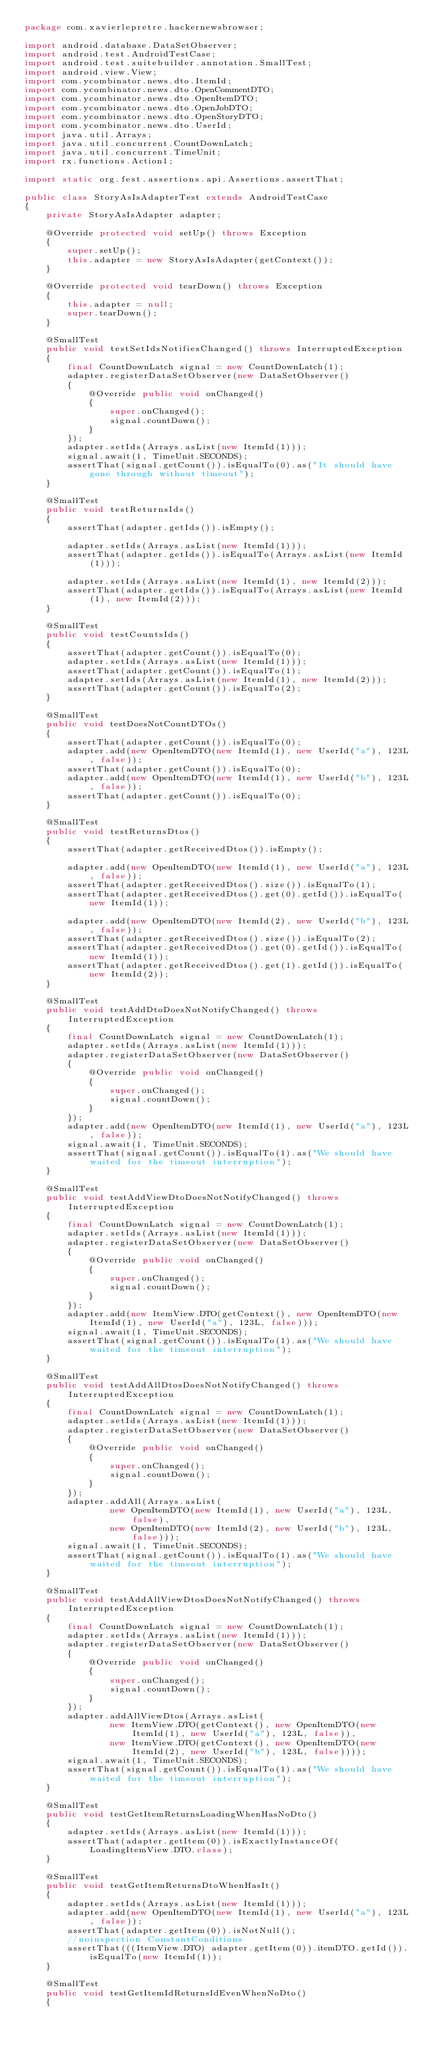<code> <loc_0><loc_0><loc_500><loc_500><_Java_>package com.xavierlepretre.hackernewsbrowser;

import android.database.DataSetObserver;
import android.test.AndroidTestCase;
import android.test.suitebuilder.annotation.SmallTest;
import android.view.View;
import com.ycombinator.news.dto.ItemId;
import com.ycombinator.news.dto.OpenCommentDTO;
import com.ycombinator.news.dto.OpenItemDTO;
import com.ycombinator.news.dto.OpenJobDTO;
import com.ycombinator.news.dto.OpenStoryDTO;
import com.ycombinator.news.dto.UserId;
import java.util.Arrays;
import java.util.concurrent.CountDownLatch;
import java.util.concurrent.TimeUnit;
import rx.functions.Action1;

import static org.fest.assertions.api.Assertions.assertThat;

public class StoryAsIsAdapterTest extends AndroidTestCase
{
    private StoryAsIsAdapter adapter;

    @Override protected void setUp() throws Exception
    {
        super.setUp();
        this.adapter = new StoryAsIsAdapter(getContext());
    }

    @Override protected void tearDown() throws Exception
    {
        this.adapter = null;
        super.tearDown();
    }

    @SmallTest
    public void testSetIdsNotifiesChanged() throws InterruptedException
    {
        final CountDownLatch signal = new CountDownLatch(1);
        adapter.registerDataSetObserver(new DataSetObserver()
        {
            @Override public void onChanged()
            {
                super.onChanged();
                signal.countDown();
            }
        });
        adapter.setIds(Arrays.asList(new ItemId(1)));
        signal.await(1, TimeUnit.SECONDS);
        assertThat(signal.getCount()).isEqualTo(0).as("It should have gone through without timeout");
    }

    @SmallTest
    public void testReturnsIds()
    {
        assertThat(adapter.getIds()).isEmpty();

        adapter.setIds(Arrays.asList(new ItemId(1)));
        assertThat(adapter.getIds()).isEqualTo(Arrays.asList(new ItemId(1)));

        adapter.setIds(Arrays.asList(new ItemId(1), new ItemId(2)));
        assertThat(adapter.getIds()).isEqualTo(Arrays.asList(new ItemId(1), new ItemId(2)));
    }

    @SmallTest
    public void testCountsIds()
    {
        assertThat(adapter.getCount()).isEqualTo(0);
        adapter.setIds(Arrays.asList(new ItemId(1)));
        assertThat(adapter.getCount()).isEqualTo(1);
        adapter.setIds(Arrays.asList(new ItemId(1), new ItemId(2)));
        assertThat(adapter.getCount()).isEqualTo(2);
    }

    @SmallTest
    public void testDoesNotCountDTOs()
    {
        assertThat(adapter.getCount()).isEqualTo(0);
        adapter.add(new OpenItemDTO(new ItemId(1), new UserId("a"), 123L, false));
        assertThat(adapter.getCount()).isEqualTo(0);
        adapter.add(new OpenItemDTO(new ItemId(1), new UserId("b"), 123L, false));
        assertThat(adapter.getCount()).isEqualTo(0);
    }

    @SmallTest
    public void testReturnsDtos()
    {
        assertThat(adapter.getReceivedDtos()).isEmpty();

        adapter.add(new OpenItemDTO(new ItemId(1), new UserId("a"), 123L, false));
        assertThat(adapter.getReceivedDtos().size()).isEqualTo(1);
        assertThat(adapter.getReceivedDtos().get(0).getId()).isEqualTo(new ItemId(1));

        adapter.add(new OpenItemDTO(new ItemId(2), new UserId("b"), 123L, false));
        assertThat(adapter.getReceivedDtos().size()).isEqualTo(2);
        assertThat(adapter.getReceivedDtos().get(0).getId()).isEqualTo(new ItemId(1));
        assertThat(adapter.getReceivedDtos().get(1).getId()).isEqualTo(new ItemId(2));
    }

    @SmallTest
    public void testAddDtoDoesNotNotifyChanged() throws InterruptedException
    {
        final CountDownLatch signal = new CountDownLatch(1);
        adapter.setIds(Arrays.asList(new ItemId(1)));
        adapter.registerDataSetObserver(new DataSetObserver()
        {
            @Override public void onChanged()
            {
                super.onChanged();
                signal.countDown();
            }
        });
        adapter.add(new OpenItemDTO(new ItemId(1), new UserId("a"), 123L, false));
        signal.await(1, TimeUnit.SECONDS);
        assertThat(signal.getCount()).isEqualTo(1).as("We should have waited for the timeout interruption");
    }

    @SmallTest
    public void testAddViewDtoDoesNotNotifyChanged() throws InterruptedException
    {
        final CountDownLatch signal = new CountDownLatch(1);
        adapter.setIds(Arrays.asList(new ItemId(1)));
        adapter.registerDataSetObserver(new DataSetObserver()
        {
            @Override public void onChanged()
            {
                super.onChanged();
                signal.countDown();
            }
        });
        adapter.add(new ItemView.DTO(getContext(), new OpenItemDTO(new ItemId(1), new UserId("a"), 123L, false)));
        signal.await(1, TimeUnit.SECONDS);
        assertThat(signal.getCount()).isEqualTo(1).as("We should have waited for the timeout interruption");
    }

    @SmallTest
    public void testAddAllDtosDoesNotNotifyChanged() throws InterruptedException
    {
        final CountDownLatch signal = new CountDownLatch(1);
        adapter.setIds(Arrays.asList(new ItemId(1)));
        adapter.registerDataSetObserver(new DataSetObserver()
        {
            @Override public void onChanged()
            {
                super.onChanged();
                signal.countDown();
            }
        });
        adapter.addAll(Arrays.asList(
                new OpenItemDTO(new ItemId(1), new UserId("a"), 123L, false),
                new OpenItemDTO(new ItemId(2), new UserId("b"), 123L, false)));
        signal.await(1, TimeUnit.SECONDS);
        assertThat(signal.getCount()).isEqualTo(1).as("We should have waited for the timeout interruption");
    }

    @SmallTest
    public void testAddAllViewDtosDoesNotNotifyChanged() throws InterruptedException
    {
        final CountDownLatch signal = new CountDownLatch(1);
        adapter.setIds(Arrays.asList(new ItemId(1)));
        adapter.registerDataSetObserver(new DataSetObserver()
        {
            @Override public void onChanged()
            {
                super.onChanged();
                signal.countDown();
            }
        });
        adapter.addAllViewDtos(Arrays.asList(
                new ItemView.DTO(getContext(), new OpenItemDTO(new ItemId(1), new UserId("a"), 123L, false)),
                new ItemView.DTO(getContext(), new OpenItemDTO(new ItemId(2), new UserId("b"), 123L, false))));
        signal.await(1, TimeUnit.SECONDS);
        assertThat(signal.getCount()).isEqualTo(1).as("We should have waited for the timeout interruption");
    }

    @SmallTest
    public void testGetItemReturnsLoadingWhenHasNoDto()
    {
        adapter.setIds(Arrays.asList(new ItemId(1)));
        assertThat(adapter.getItem(0)).isExactlyInstanceOf(LoadingItemView.DTO.class);
    }

    @SmallTest
    public void testGetItemReturnsDtoWhenHasIt()
    {
        adapter.setIds(Arrays.asList(new ItemId(1)));
        adapter.add(new OpenItemDTO(new ItemId(1), new UserId("a"), 123L, false));
        assertThat(adapter.getItem(0)).isNotNull();
        //noinspection ConstantConditions
        assertThat(((ItemView.DTO) adapter.getItem(0)).itemDTO.getId()).isEqualTo(new ItemId(1));
    }

    @SmallTest
    public void testGetItemIdReturnsIdEvenWhenNoDto()
    {</code> 